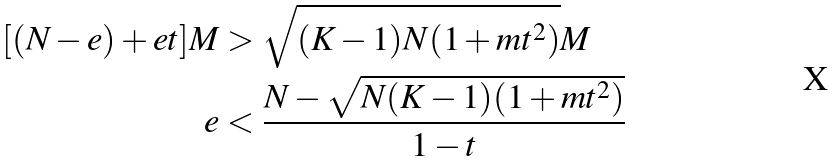Convert formula to latex. <formula><loc_0><loc_0><loc_500><loc_500>[ ( N - e ) + e t ] M & > \sqrt { ( K - 1 ) N ( 1 + m t ^ { 2 } ) } M \\ e & < \frac { N - \sqrt { N ( K - 1 ) ( 1 + m t ^ { 2 } ) } } { 1 - t }</formula> 